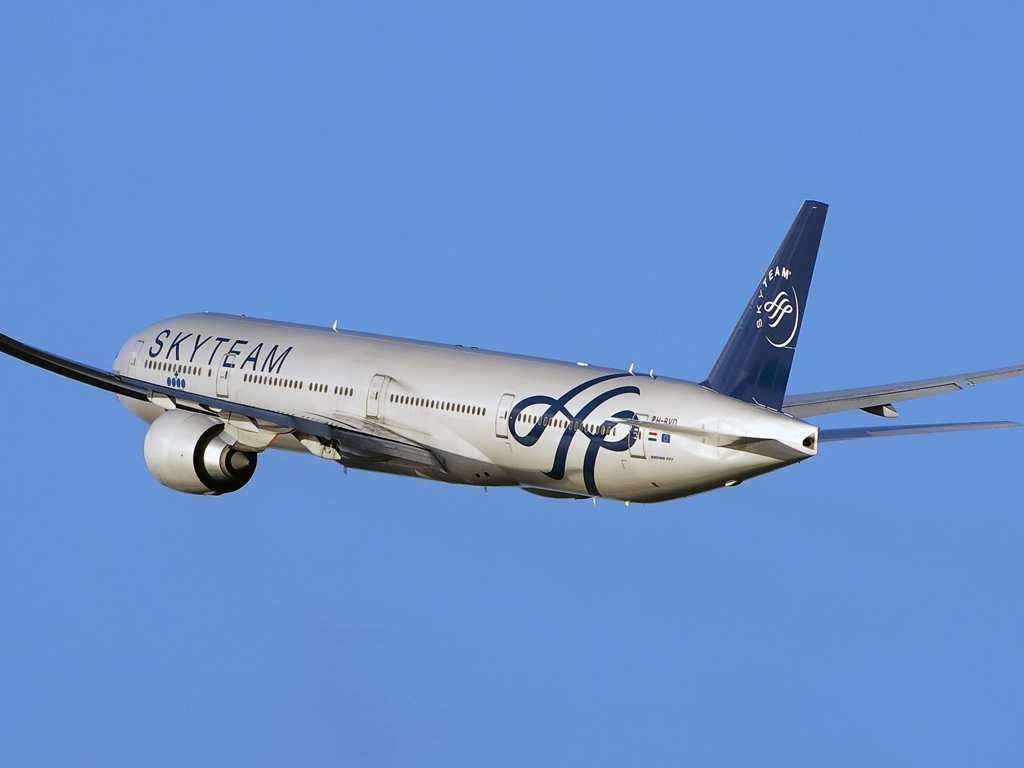Why is the image considered to have good quality?
A. Colors are vibrant
B. Details are lost
C. Details are well-preserved
Answer with the option's letter from the given choices directly.
 C. 